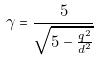<formula> <loc_0><loc_0><loc_500><loc_500>\gamma = \frac { 5 } { \sqrt { 5 - \frac { q ^ { 2 } } { d ^ { 2 } } } }</formula> 